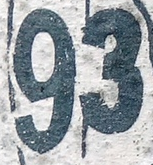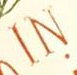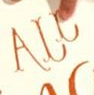What text is displayed in these images sequentially, separated by a semicolon? 93; IN; ALL 